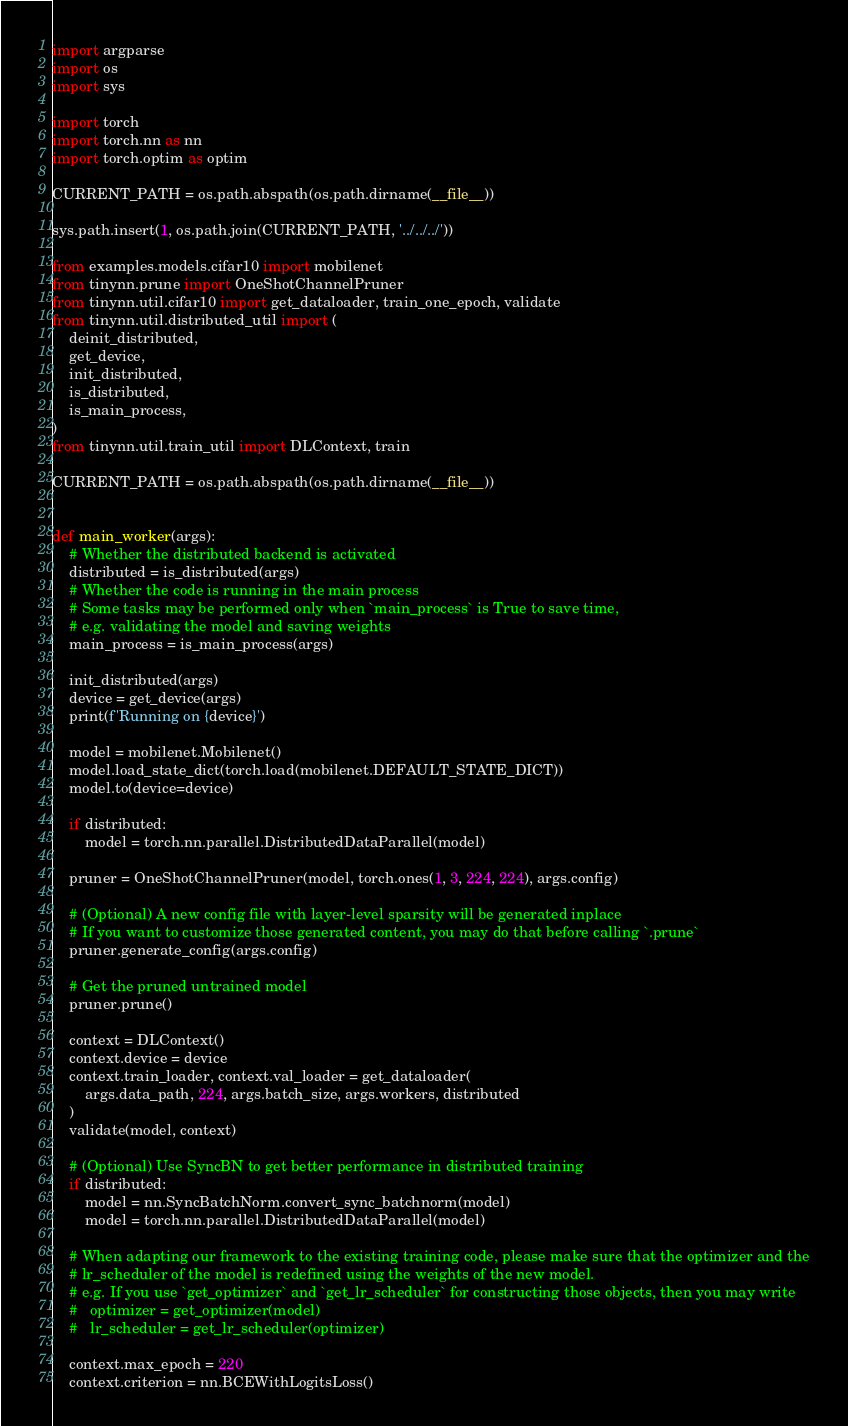<code> <loc_0><loc_0><loc_500><loc_500><_Python_>import argparse
import os
import sys

import torch
import torch.nn as nn
import torch.optim as optim

CURRENT_PATH = os.path.abspath(os.path.dirname(__file__))

sys.path.insert(1, os.path.join(CURRENT_PATH, '../../../'))

from examples.models.cifar10 import mobilenet
from tinynn.prune import OneShotChannelPruner
from tinynn.util.cifar10 import get_dataloader, train_one_epoch, validate
from tinynn.util.distributed_util import (
    deinit_distributed,
    get_device,
    init_distributed,
    is_distributed,
    is_main_process,
)
from tinynn.util.train_util import DLContext, train

CURRENT_PATH = os.path.abspath(os.path.dirname(__file__))


def main_worker(args):
    # Whether the distributed backend is activated
    distributed = is_distributed(args)
    # Whether the code is running in the main process
    # Some tasks may be performed only when `main_process` is True to save time,
    # e.g. validating the model and saving weights
    main_process = is_main_process(args)

    init_distributed(args)
    device = get_device(args)
    print(f'Running on {device}')

    model = mobilenet.Mobilenet()
    model.load_state_dict(torch.load(mobilenet.DEFAULT_STATE_DICT))
    model.to(device=device)

    if distributed:
        model = torch.nn.parallel.DistributedDataParallel(model)

    pruner = OneShotChannelPruner(model, torch.ones(1, 3, 224, 224), args.config)

    # (Optional) A new config file with layer-level sparsity will be generated inplace
    # If you want to customize those generated content, you may do that before calling `.prune`
    pruner.generate_config(args.config)

    # Get the pruned untrained model
    pruner.prune()

    context = DLContext()
    context.device = device
    context.train_loader, context.val_loader = get_dataloader(
        args.data_path, 224, args.batch_size, args.workers, distributed
    )
    validate(model, context)

    # (Optional) Use SyncBN to get better performance in distributed training
    if distributed:
        model = nn.SyncBatchNorm.convert_sync_batchnorm(model)
        model = torch.nn.parallel.DistributedDataParallel(model)

    # When adapting our framework to the existing training code, please make sure that the optimizer and the
    # lr_scheduler of the model is redefined using the weights of the new model.
    # e.g. If you use `get_optimizer` and `get_lr_scheduler` for constructing those objects, then you may write
    #   optimizer = get_optimizer(model)
    #   lr_scheduler = get_lr_scheduler(optimizer)

    context.max_epoch = 220
    context.criterion = nn.BCEWithLogitsLoss()</code> 